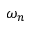Convert formula to latex. <formula><loc_0><loc_0><loc_500><loc_500>\omega _ { n }</formula> 